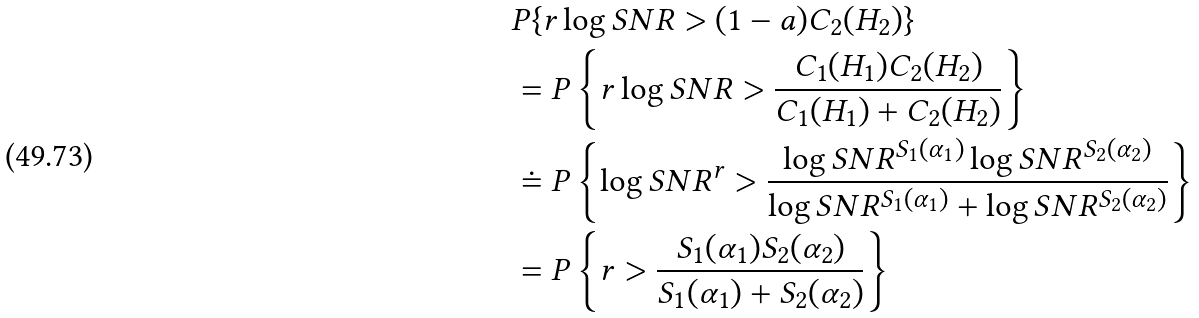Convert formula to latex. <formula><loc_0><loc_0><loc_500><loc_500>& P \{ r \log S N R > ( 1 - a ) C _ { 2 } ( H _ { 2 } ) \} \\ & = P \left \{ r \log S N R > \frac { C _ { 1 } ( H _ { 1 } ) C _ { 2 } ( H _ { 2 } ) } { C _ { 1 } ( H _ { 1 } ) + C _ { 2 } ( H _ { 2 } ) } \right \} \\ & \doteq P \left \{ \log S N R ^ { r } > \frac { \log S N R ^ { S _ { 1 } ( \alpha _ { 1 } ) } \log S N R ^ { S _ { 2 } ( \alpha _ { 2 } ) } } { \log S N R ^ { S _ { 1 } ( \alpha _ { 1 } ) } + \log S N R ^ { S _ { 2 } ( \alpha _ { 2 } ) } } \right \} \\ & = P \left \{ r > \frac { S _ { 1 } ( \alpha _ { 1 } ) S _ { 2 } ( \alpha _ { 2 } ) } { S _ { 1 } ( \alpha _ { 1 } ) + S _ { 2 } ( \alpha _ { 2 } ) } \right \}</formula> 